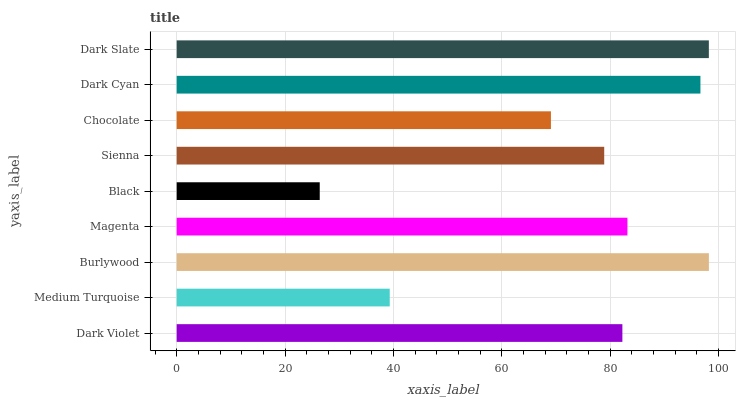Is Black the minimum?
Answer yes or no. Yes. Is Burlywood the maximum?
Answer yes or no. Yes. Is Medium Turquoise the minimum?
Answer yes or no. No. Is Medium Turquoise the maximum?
Answer yes or no. No. Is Dark Violet greater than Medium Turquoise?
Answer yes or no. Yes. Is Medium Turquoise less than Dark Violet?
Answer yes or no. Yes. Is Medium Turquoise greater than Dark Violet?
Answer yes or no. No. Is Dark Violet less than Medium Turquoise?
Answer yes or no. No. Is Dark Violet the high median?
Answer yes or no. Yes. Is Dark Violet the low median?
Answer yes or no. Yes. Is Black the high median?
Answer yes or no. No. Is Black the low median?
Answer yes or no. No. 